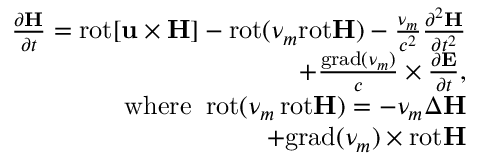<formula> <loc_0><loc_0><loc_500><loc_500>\begin{array} { r } { \frac { \partial { H } } { \partial t } = r o t { [ u \times H ] } - r o t ( \nu _ { m } r o t { H } ) - \frac { \nu _ { m } } { c ^ { 2 } } \frac { \partial ^ { 2 } { H } } { \partial t ^ { 2 } } \quad } \\ { + \frac { g r a d ( \nu _ { m } ) } { c } \times \frac { \partial { E } } { \partial t } , \quad } \\ { { w h e r e } \, r o t ( \nu _ { m } \, r o t { H } ) = - \nu _ { m } \Delta { H } \quad } \\ { + g r a d ( \nu _ { m } ) \times r o t { H } \quad } \end{array}</formula> 